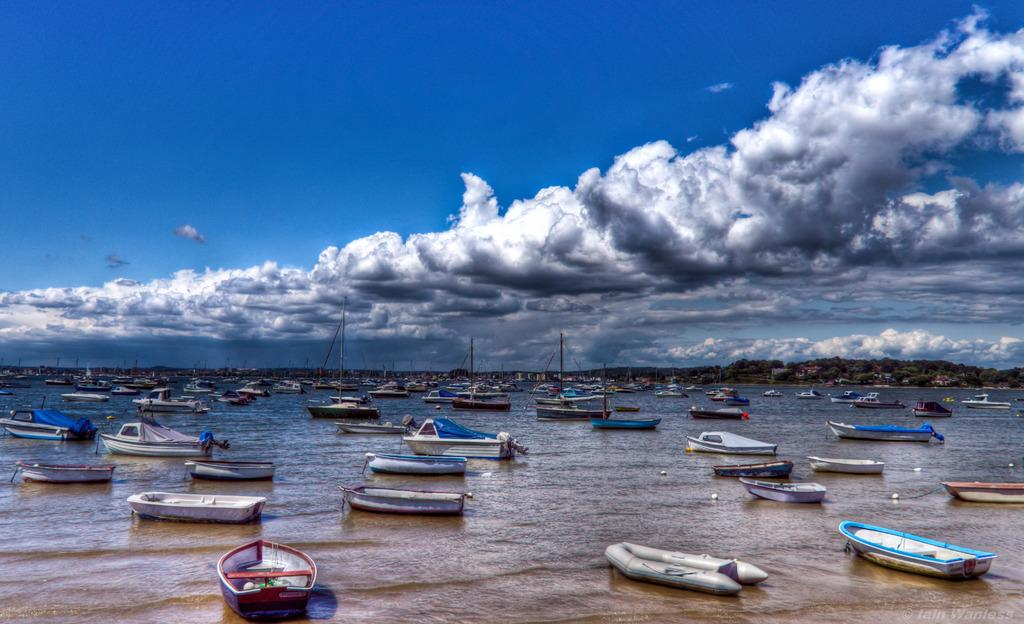What is present on the water in the image? There are boats on the water in the image. What can be seen in the distance behind the boats? There are trees visible in the background of the image. How would you describe the sky in the image? The sky is cloudy in the background of the image. Is there any additional information about the image itself? Yes, there is a watermark on the image. How does the girl feel about the frog in the image? There is no girl or frog present in the image, so it is not possible to answer that question. 